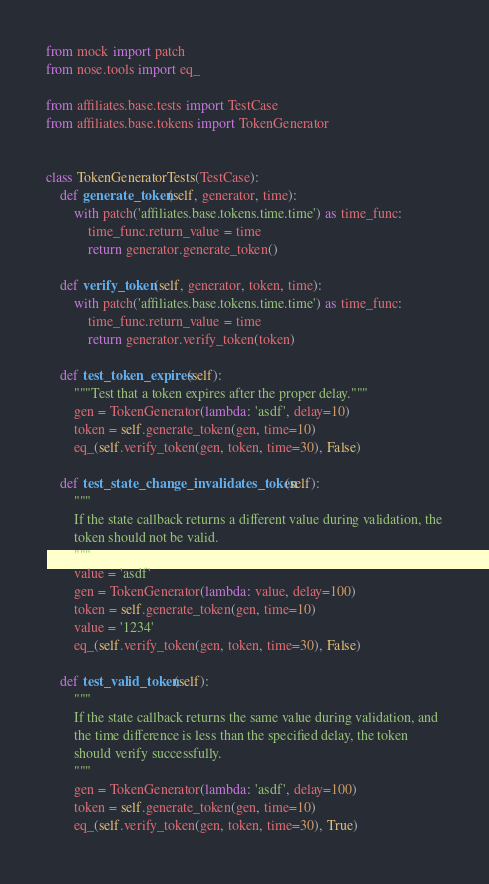Convert code to text. <code><loc_0><loc_0><loc_500><loc_500><_Python_>from mock import patch
from nose.tools import eq_

from affiliates.base.tests import TestCase
from affiliates.base.tokens import TokenGenerator


class TokenGeneratorTests(TestCase):
    def generate_token(self, generator, time):
        with patch('affiliates.base.tokens.time.time') as time_func:
            time_func.return_value = time
            return generator.generate_token()

    def verify_token(self, generator, token, time):
        with patch('affiliates.base.tokens.time.time') as time_func:
            time_func.return_value = time
            return generator.verify_token(token)

    def test_token_expires(self):
        """Test that a token expires after the proper delay."""
        gen = TokenGenerator(lambda: 'asdf', delay=10)
        token = self.generate_token(gen, time=10)
        eq_(self.verify_token(gen, token, time=30), False)

    def test_state_change_invalidates_token(self):
        """
        If the state callback returns a different value during validation, the
        token should not be valid.
        """
        value = 'asdf'
        gen = TokenGenerator(lambda: value, delay=100)
        token = self.generate_token(gen, time=10)
        value = '1234'
        eq_(self.verify_token(gen, token, time=30), False)

    def test_valid_token(self):
        """
        If the state callback returns the same value during validation, and
        the time difference is less than the specified delay, the token
        should verify successfully.
        """
        gen = TokenGenerator(lambda: 'asdf', delay=100)
        token = self.generate_token(gen, time=10)
        eq_(self.verify_token(gen, token, time=30), True)
</code> 